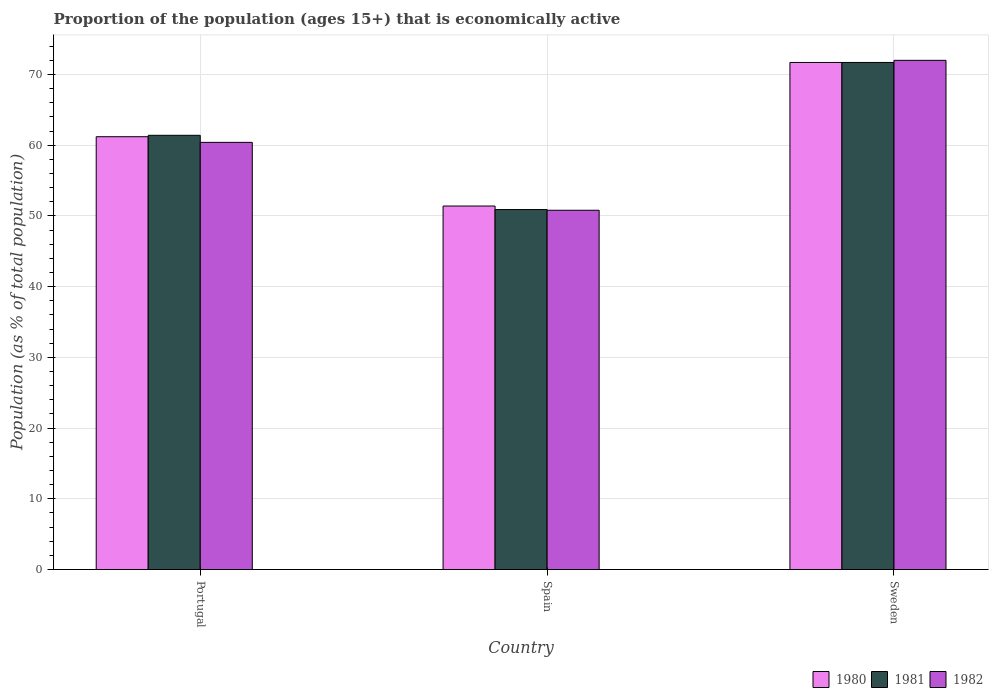Are the number of bars per tick equal to the number of legend labels?
Ensure brevity in your answer.  Yes. Are the number of bars on each tick of the X-axis equal?
Keep it short and to the point. Yes. How many bars are there on the 1st tick from the left?
Keep it short and to the point. 3. How many bars are there on the 1st tick from the right?
Offer a terse response. 3. In how many cases, is the number of bars for a given country not equal to the number of legend labels?
Make the answer very short. 0. What is the proportion of the population that is economically active in 1982 in Sweden?
Your answer should be compact. 72. Across all countries, what is the maximum proportion of the population that is economically active in 1982?
Your response must be concise. 72. Across all countries, what is the minimum proportion of the population that is economically active in 1982?
Offer a terse response. 50.8. In which country was the proportion of the population that is economically active in 1981 maximum?
Your answer should be very brief. Sweden. What is the total proportion of the population that is economically active in 1981 in the graph?
Provide a succinct answer. 184. What is the difference between the proportion of the population that is economically active in 1982 in Portugal and that in Sweden?
Provide a succinct answer. -11.6. What is the difference between the proportion of the population that is economically active in 1980 in Spain and the proportion of the population that is economically active in 1982 in Portugal?
Provide a short and direct response. -9. What is the average proportion of the population that is economically active in 1981 per country?
Your answer should be very brief. 61.33. What is the difference between the proportion of the population that is economically active of/in 1982 and proportion of the population that is economically active of/in 1980 in Spain?
Offer a very short reply. -0.6. In how many countries, is the proportion of the population that is economically active in 1982 greater than 24 %?
Provide a short and direct response. 3. What is the ratio of the proportion of the population that is economically active in 1980 in Portugal to that in Sweden?
Provide a short and direct response. 0.85. Is the proportion of the population that is economically active in 1980 in Portugal less than that in Spain?
Offer a terse response. No. What is the difference between the highest and the second highest proportion of the population that is economically active in 1980?
Ensure brevity in your answer.  -9.8. What is the difference between the highest and the lowest proportion of the population that is economically active in 1981?
Provide a short and direct response. 20.8. How many bars are there?
Your response must be concise. 9. What is the difference between two consecutive major ticks on the Y-axis?
Ensure brevity in your answer.  10. Where does the legend appear in the graph?
Provide a short and direct response. Bottom right. How many legend labels are there?
Give a very brief answer. 3. What is the title of the graph?
Ensure brevity in your answer.  Proportion of the population (ages 15+) that is economically active. What is the label or title of the Y-axis?
Give a very brief answer. Population (as % of total population). What is the Population (as % of total population) of 1980 in Portugal?
Your answer should be compact. 61.2. What is the Population (as % of total population) of 1981 in Portugal?
Your answer should be very brief. 61.4. What is the Population (as % of total population) in 1982 in Portugal?
Ensure brevity in your answer.  60.4. What is the Population (as % of total population) in 1980 in Spain?
Give a very brief answer. 51.4. What is the Population (as % of total population) of 1981 in Spain?
Provide a short and direct response. 50.9. What is the Population (as % of total population) in 1982 in Spain?
Offer a terse response. 50.8. What is the Population (as % of total population) of 1980 in Sweden?
Ensure brevity in your answer.  71.7. What is the Population (as % of total population) in 1981 in Sweden?
Offer a terse response. 71.7. What is the Population (as % of total population) of 1982 in Sweden?
Your answer should be very brief. 72. Across all countries, what is the maximum Population (as % of total population) in 1980?
Your response must be concise. 71.7. Across all countries, what is the maximum Population (as % of total population) of 1981?
Offer a very short reply. 71.7. Across all countries, what is the maximum Population (as % of total population) in 1982?
Your response must be concise. 72. Across all countries, what is the minimum Population (as % of total population) in 1980?
Your answer should be very brief. 51.4. Across all countries, what is the minimum Population (as % of total population) in 1981?
Give a very brief answer. 50.9. Across all countries, what is the minimum Population (as % of total population) of 1982?
Provide a succinct answer. 50.8. What is the total Population (as % of total population) in 1980 in the graph?
Provide a succinct answer. 184.3. What is the total Population (as % of total population) in 1981 in the graph?
Give a very brief answer. 184. What is the total Population (as % of total population) in 1982 in the graph?
Offer a very short reply. 183.2. What is the difference between the Population (as % of total population) of 1980 in Portugal and that in Spain?
Offer a very short reply. 9.8. What is the difference between the Population (as % of total population) in 1982 in Portugal and that in Spain?
Ensure brevity in your answer.  9.6. What is the difference between the Population (as % of total population) of 1981 in Portugal and that in Sweden?
Provide a short and direct response. -10.3. What is the difference between the Population (as % of total population) in 1982 in Portugal and that in Sweden?
Ensure brevity in your answer.  -11.6. What is the difference between the Population (as % of total population) of 1980 in Spain and that in Sweden?
Provide a short and direct response. -20.3. What is the difference between the Population (as % of total population) of 1981 in Spain and that in Sweden?
Offer a terse response. -20.8. What is the difference between the Population (as % of total population) in 1982 in Spain and that in Sweden?
Your answer should be very brief. -21.2. What is the difference between the Population (as % of total population) of 1980 in Portugal and the Population (as % of total population) of 1982 in Spain?
Make the answer very short. 10.4. What is the difference between the Population (as % of total population) in 1980 in Portugal and the Population (as % of total population) in 1982 in Sweden?
Provide a succinct answer. -10.8. What is the difference between the Population (as % of total population) in 1981 in Portugal and the Population (as % of total population) in 1982 in Sweden?
Offer a very short reply. -10.6. What is the difference between the Population (as % of total population) in 1980 in Spain and the Population (as % of total population) in 1981 in Sweden?
Keep it short and to the point. -20.3. What is the difference between the Population (as % of total population) in 1980 in Spain and the Population (as % of total population) in 1982 in Sweden?
Ensure brevity in your answer.  -20.6. What is the difference between the Population (as % of total population) in 1981 in Spain and the Population (as % of total population) in 1982 in Sweden?
Your answer should be very brief. -21.1. What is the average Population (as % of total population) in 1980 per country?
Provide a succinct answer. 61.43. What is the average Population (as % of total population) of 1981 per country?
Your answer should be compact. 61.33. What is the average Population (as % of total population) of 1982 per country?
Your response must be concise. 61.07. What is the difference between the Population (as % of total population) of 1980 and Population (as % of total population) of 1981 in Spain?
Give a very brief answer. 0.5. What is the difference between the Population (as % of total population) of 1980 and Population (as % of total population) of 1982 in Spain?
Offer a very short reply. 0.6. What is the difference between the Population (as % of total population) of 1980 and Population (as % of total population) of 1982 in Sweden?
Keep it short and to the point. -0.3. What is the difference between the Population (as % of total population) of 1981 and Population (as % of total population) of 1982 in Sweden?
Your answer should be very brief. -0.3. What is the ratio of the Population (as % of total population) in 1980 in Portugal to that in Spain?
Your answer should be very brief. 1.19. What is the ratio of the Population (as % of total population) in 1981 in Portugal to that in Spain?
Provide a succinct answer. 1.21. What is the ratio of the Population (as % of total population) in 1982 in Portugal to that in Spain?
Give a very brief answer. 1.19. What is the ratio of the Population (as % of total population) of 1980 in Portugal to that in Sweden?
Keep it short and to the point. 0.85. What is the ratio of the Population (as % of total population) of 1981 in Portugal to that in Sweden?
Your answer should be very brief. 0.86. What is the ratio of the Population (as % of total population) of 1982 in Portugal to that in Sweden?
Provide a succinct answer. 0.84. What is the ratio of the Population (as % of total population) in 1980 in Spain to that in Sweden?
Your response must be concise. 0.72. What is the ratio of the Population (as % of total population) of 1981 in Spain to that in Sweden?
Your answer should be very brief. 0.71. What is the ratio of the Population (as % of total population) in 1982 in Spain to that in Sweden?
Ensure brevity in your answer.  0.71. What is the difference between the highest and the second highest Population (as % of total population) in 1981?
Keep it short and to the point. 10.3. What is the difference between the highest and the lowest Population (as % of total population) of 1980?
Ensure brevity in your answer.  20.3. What is the difference between the highest and the lowest Population (as % of total population) of 1981?
Ensure brevity in your answer.  20.8. What is the difference between the highest and the lowest Population (as % of total population) of 1982?
Keep it short and to the point. 21.2. 